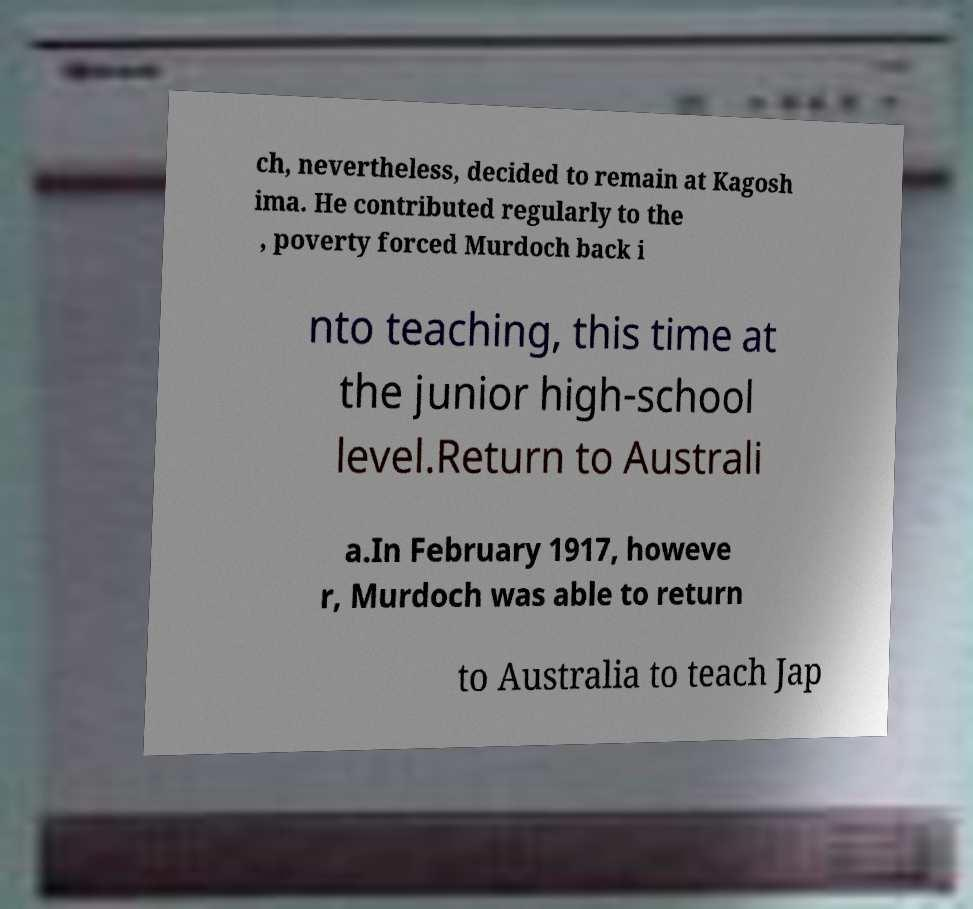Can you read and provide the text displayed in the image?This photo seems to have some interesting text. Can you extract and type it out for me? ch, nevertheless, decided to remain at Kagosh ima. He contributed regularly to the , poverty forced Murdoch back i nto teaching, this time at the junior high-school level.Return to Australi a.In February 1917, howeve r, Murdoch was able to return to Australia to teach Jap 